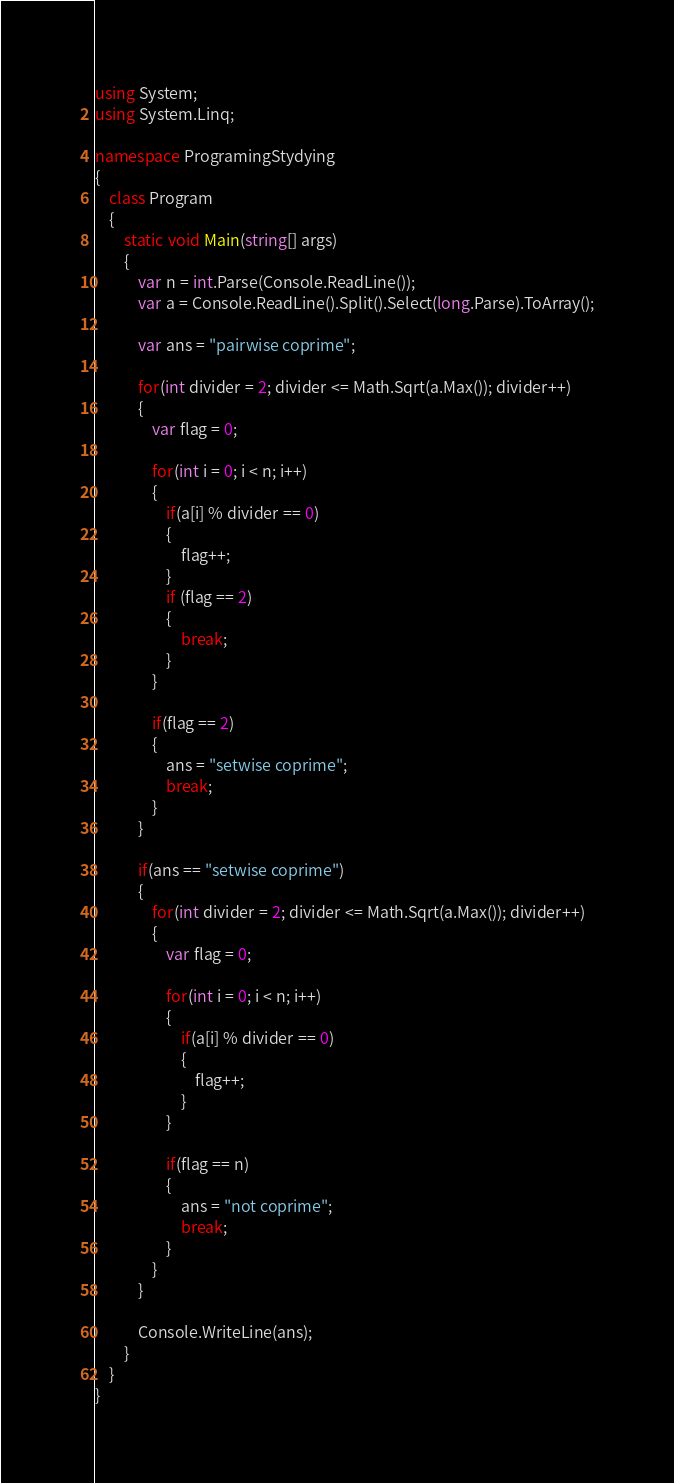Convert code to text. <code><loc_0><loc_0><loc_500><loc_500><_C#_>using System;
using System.Linq;

namespace ProgramingStydying
{
    class Program
    {
        static void Main(string[] args)
        {
            var n = int.Parse(Console.ReadLine());
            var a = Console.ReadLine().Split().Select(long.Parse).ToArray();

            var ans = "pairwise coprime";

            for(int divider = 2; divider <= Math.Sqrt(a.Max()); divider++)
            {
                var flag = 0;

                for(int i = 0; i < n; i++)
                {
                    if(a[i] % divider == 0)
                    {
                        flag++;
                    }
                    if (flag == 2)
                    {
                        break;
                    }
                }

                if(flag == 2)
                {
                    ans = "setwise coprime";
                    break;
                }
            }

            if(ans == "setwise coprime")
            {
                for(int divider = 2; divider <= Math.Sqrt(a.Max()); divider++)
                {
                    var flag = 0;

                    for(int i = 0; i < n; i++)
                    {
                        if(a[i] % divider == 0)
                        {
                            flag++;
                        }
                    }

                    if(flag == n)
                    {
                        ans = "not coprime";
                        break;
                    }
                }
            }

            Console.WriteLine(ans);
        }
    }
}</code> 